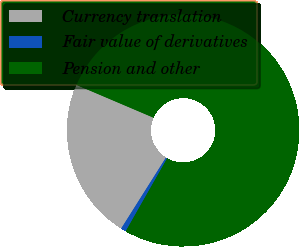<chart> <loc_0><loc_0><loc_500><loc_500><pie_chart><fcel>Currency translation<fcel>Fair value of derivatives<fcel>Pension and other<nl><fcel>22.45%<fcel>0.73%<fcel>76.82%<nl></chart> 